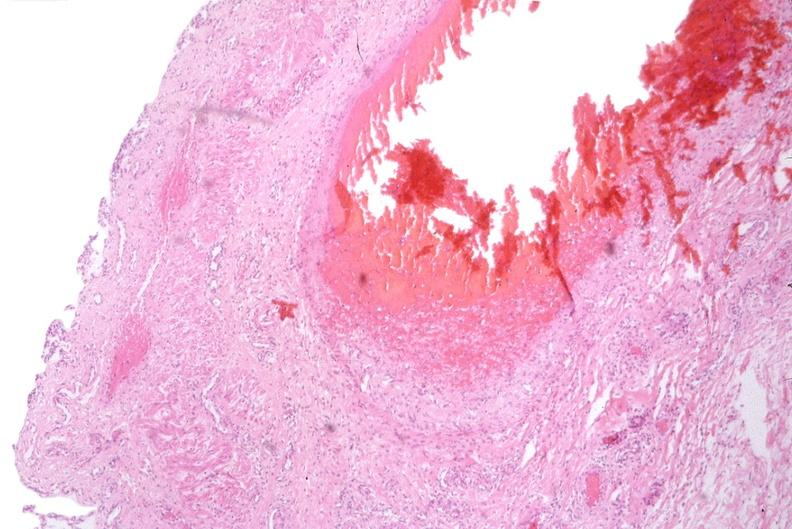s gastrointestinal present?
Answer the question using a single word or phrase. Yes 